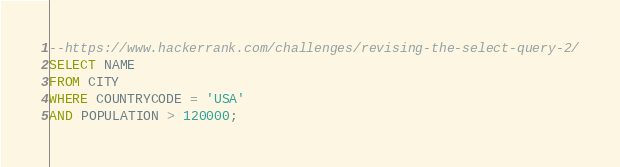Convert code to text. <code><loc_0><loc_0><loc_500><loc_500><_SQL_>--https://www.hackerrank.com/challenges/revising-the-select-query-2/
SELECT NAME
FROM CITY
WHERE COUNTRYCODE = 'USA'
AND POPULATION > 120000;
</code> 